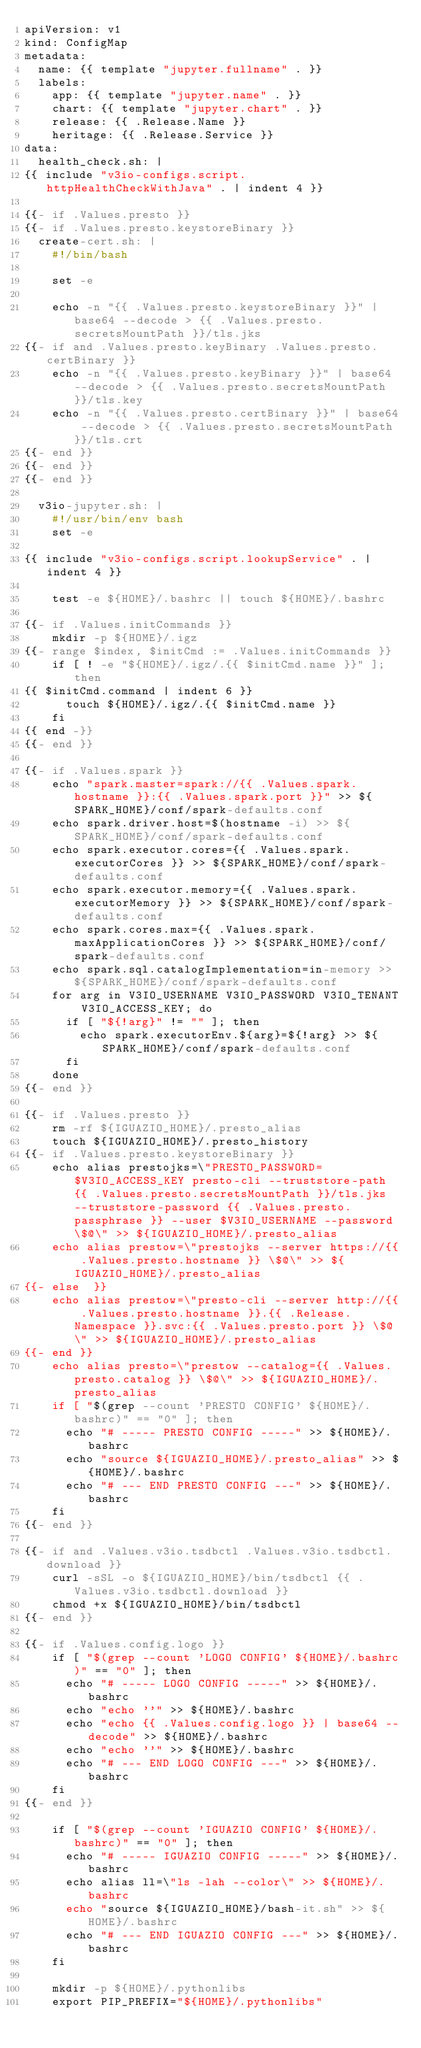Convert code to text. <code><loc_0><loc_0><loc_500><loc_500><_YAML_>apiVersion: v1
kind: ConfigMap
metadata:
  name: {{ template "jupyter.fullname" . }}
  labels:
    app: {{ template "jupyter.name" . }}
    chart: {{ template "jupyter.chart" . }}
    release: {{ .Release.Name }}
    heritage: {{ .Release.Service }}
data:
  health_check.sh: |
{{ include "v3io-configs.script.httpHealthCheckWithJava" . | indent 4 }}

{{- if .Values.presto }}
{{- if .Values.presto.keystoreBinary }}
  create-cert.sh: |
    #!/bin/bash

    set -e

    echo -n "{{ .Values.presto.keystoreBinary }}" | base64 --decode > {{ .Values.presto.secretsMountPath }}/tls.jks
{{- if and .Values.presto.keyBinary .Values.presto.certBinary }}
    echo -n "{{ .Values.presto.keyBinary }}" | base64 --decode > {{ .Values.presto.secretsMountPath }}/tls.key
    echo -n "{{ .Values.presto.certBinary }}" | base64 --decode > {{ .Values.presto.secretsMountPath }}/tls.crt
{{- end }}
{{- end }}
{{- end }}

  v3io-jupyter.sh: |
    #!/usr/bin/env bash
    set -e

{{ include "v3io-configs.script.lookupService" . | indent 4 }}

    test -e ${HOME}/.bashrc || touch ${HOME}/.bashrc

{{- if .Values.initCommands }}
    mkdir -p ${HOME}/.igz
{{- range $index, $initCmd := .Values.initCommands }}
    if [ ! -e "${HOME}/.igz/.{{ $initCmd.name }}" ]; then
{{ $initCmd.command | indent 6 }}
      touch ${HOME}/.igz/.{{ $initCmd.name }}
    fi
{{ end -}}
{{- end }}

{{- if .Values.spark }}
    echo "spark.master=spark://{{ .Values.spark.hostname }}:{{ .Values.spark.port }}" >> ${SPARK_HOME}/conf/spark-defaults.conf
    echo spark.driver.host=$(hostname -i) >> ${SPARK_HOME}/conf/spark-defaults.conf
    echo spark.executor.cores={{ .Values.spark.executorCores }} >> ${SPARK_HOME}/conf/spark-defaults.conf
    echo spark.executor.memory={{ .Values.spark.executorMemory }} >> ${SPARK_HOME}/conf/spark-defaults.conf
    echo spark.cores.max={{ .Values.spark.maxApplicationCores }} >> ${SPARK_HOME}/conf/spark-defaults.conf
    echo spark.sql.catalogImplementation=in-memory >> ${SPARK_HOME}/conf/spark-defaults.conf
    for arg in V3IO_USERNAME V3IO_PASSWORD V3IO_TENANT V3IO_ACCESS_KEY; do
      if [ "${!arg}" != "" ]; then
        echo spark.executorEnv.${arg}=${!arg} >> ${SPARK_HOME}/conf/spark-defaults.conf
      fi
    done
{{- end }}

{{- if .Values.presto }}
    rm -rf ${IGUAZIO_HOME}/.presto_alias
    touch ${IGUAZIO_HOME}/.presto_history
{{- if .Values.presto.keystoreBinary }}
    echo alias prestojks=\"PRESTO_PASSWORD=$V3IO_ACCESS_KEY presto-cli --truststore-path {{ .Values.presto.secretsMountPath }}/tls.jks --truststore-password {{ .Values.presto.passphrase }} --user $V3IO_USERNAME --password \$@\" >> ${IGUAZIO_HOME}/.presto_alias
    echo alias prestow=\"prestojks --server https://{{ .Values.presto.hostname }} \$@\" >> ${IGUAZIO_HOME}/.presto_alias
{{- else  }}
    echo alias prestow=\"presto-cli --server http://{{ .Values.presto.hostname }}.{{ .Release.Namespace }}.svc:{{ .Values.presto.port }} \$@\" >> ${IGUAZIO_HOME}/.presto_alias
{{- end }}
    echo alias presto=\"prestow --catalog={{ .Values.presto.catalog }} \$@\" >> ${IGUAZIO_HOME}/.presto_alias
    if [ "$(grep --count 'PRESTO CONFIG' ${HOME}/.bashrc)" == "0" ]; then
      echo "# ----- PRESTO CONFIG -----" >> ${HOME}/.bashrc
      echo "source ${IGUAZIO_HOME}/.presto_alias" >> ${HOME}/.bashrc
      echo "# --- END PRESTO CONFIG ---" >> ${HOME}/.bashrc
    fi
{{- end }}

{{- if and .Values.v3io.tsdbctl .Values.v3io.tsdbctl.download }}
    curl -sSL -o ${IGUAZIO_HOME}/bin/tsdbctl {{ .Values.v3io.tsdbctl.download }}
    chmod +x ${IGUAZIO_HOME}/bin/tsdbctl
{{- end }}

{{- if .Values.config.logo }}
    if [ "$(grep --count 'LOGO CONFIG' ${HOME}/.bashrc)" == "0" ]; then
      echo "# ----- LOGO CONFIG -----" >> ${HOME}/.bashrc
      echo "echo ''" >> ${HOME}/.bashrc
      echo "echo {{ .Values.config.logo }} | base64 --decode" >> ${HOME}/.bashrc
      echo "echo ''" >> ${HOME}/.bashrc
      echo "# --- END LOGO CONFIG ---" >> ${HOME}/.bashrc
    fi
{{- end }}

    if [ "$(grep --count 'IGUAZIO CONFIG' ${HOME}/.bashrc)" == "0" ]; then
      echo "# ----- IGUAZIO CONFIG -----" >> ${HOME}/.bashrc
      echo alias ll=\"ls -lah --color\" >> ${HOME}/.bashrc
      echo "source ${IGUAZIO_HOME}/bash-it.sh" >> ${HOME}/.bashrc
      echo "# --- END IGUAZIO CONFIG ---" >> ${HOME}/.bashrc
    fi

    mkdir -p ${HOME}/.pythonlibs
    export PIP_PREFIX="${HOME}/.pythonlibs"</code> 